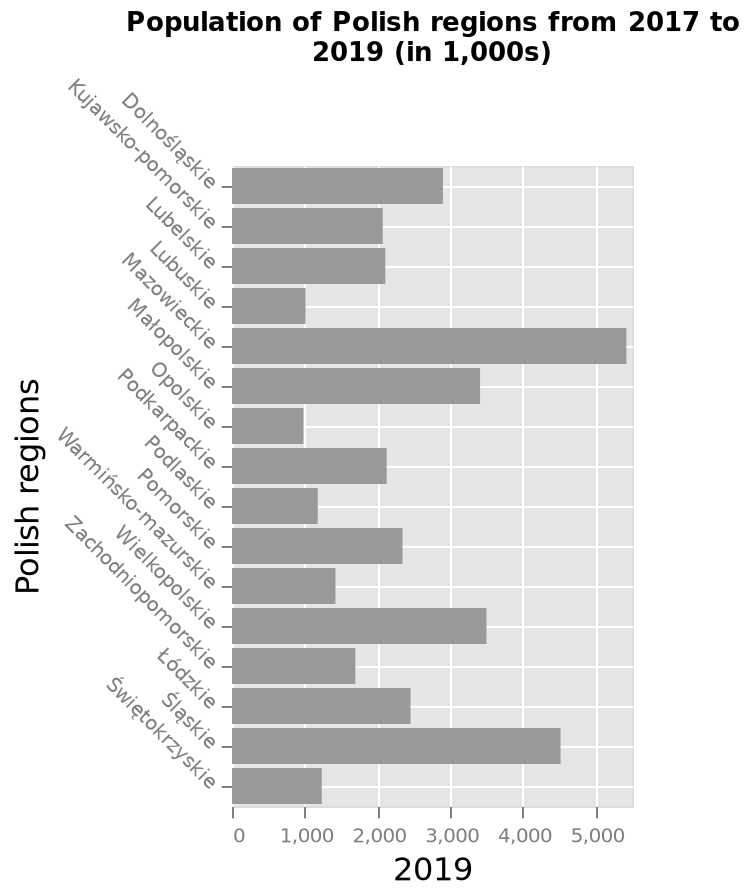<image>
In which year does the data for the population of Polish regions end? The data for the population of Polish regions ends in the year 2019. 